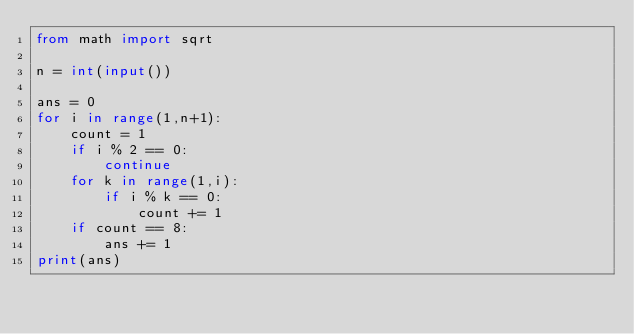Convert code to text. <code><loc_0><loc_0><loc_500><loc_500><_Python_>from math import sqrt

n = int(input())

ans = 0
for i in range(1,n+1):
    count = 1
    if i % 2 == 0:
        continue
    for k in range(1,i):
        if i % k == 0:
            count += 1
    if count == 8:
        ans += 1
print(ans)
</code> 